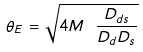Convert formula to latex. <formula><loc_0><loc_0><loc_500><loc_500>\theta _ { E } = \sqrt { 4 M \ \frac { D _ { d s } } { D _ { d } D _ { s } } }</formula> 